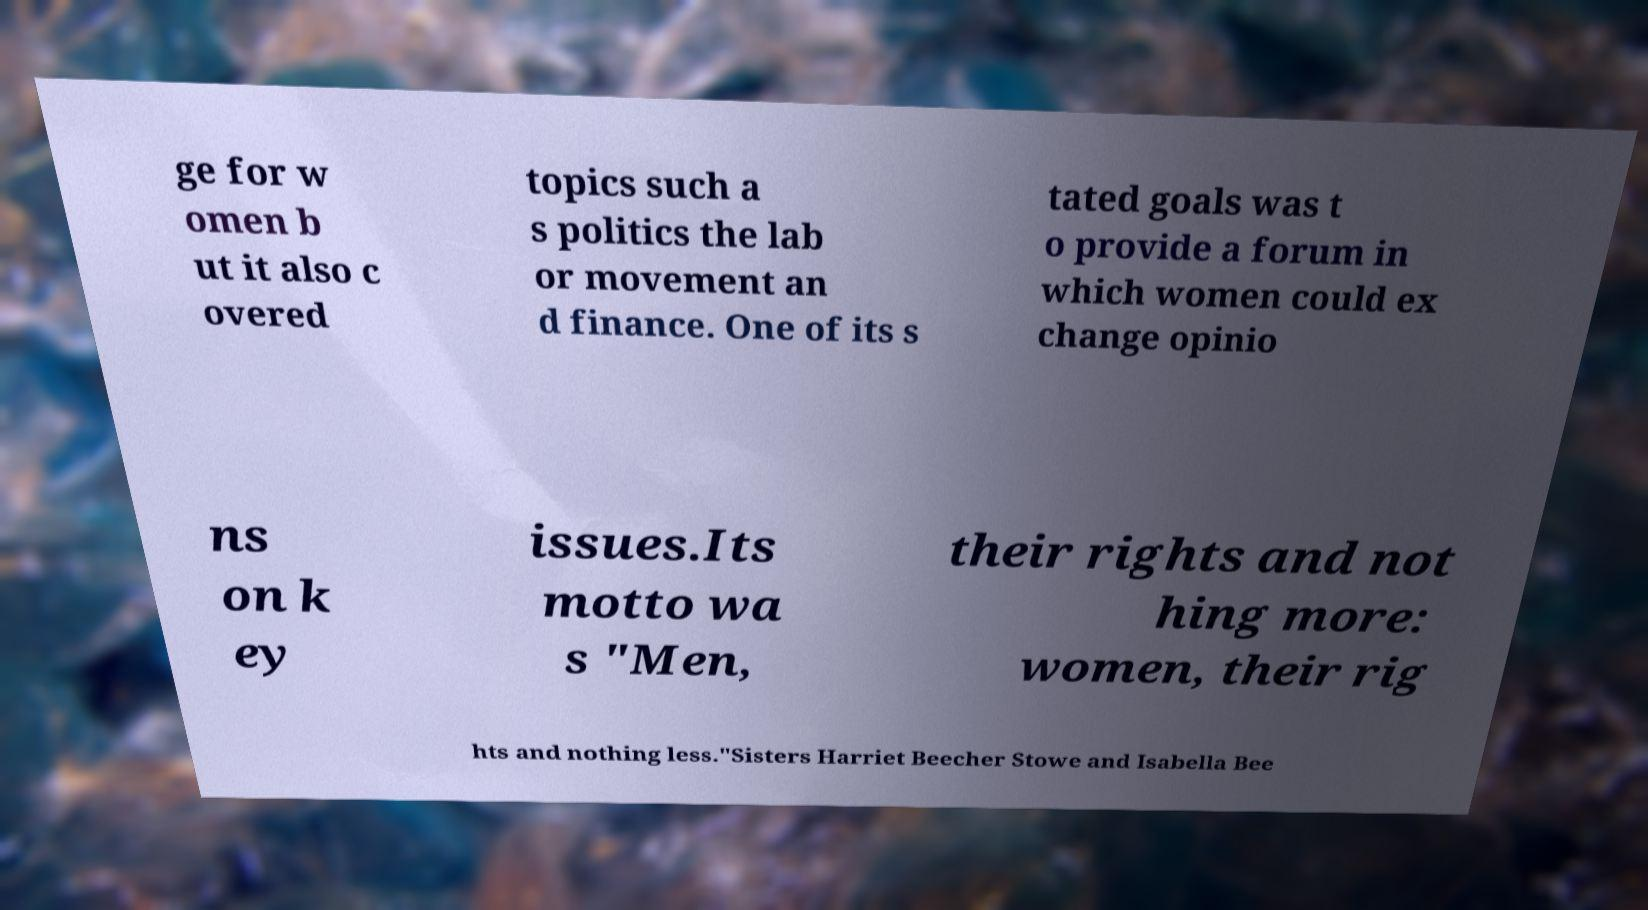For documentation purposes, I need the text within this image transcribed. Could you provide that? ge for w omen b ut it also c overed topics such a s politics the lab or movement an d finance. One of its s tated goals was t o provide a forum in which women could ex change opinio ns on k ey issues.Its motto wa s "Men, their rights and not hing more: women, their rig hts and nothing less."Sisters Harriet Beecher Stowe and Isabella Bee 